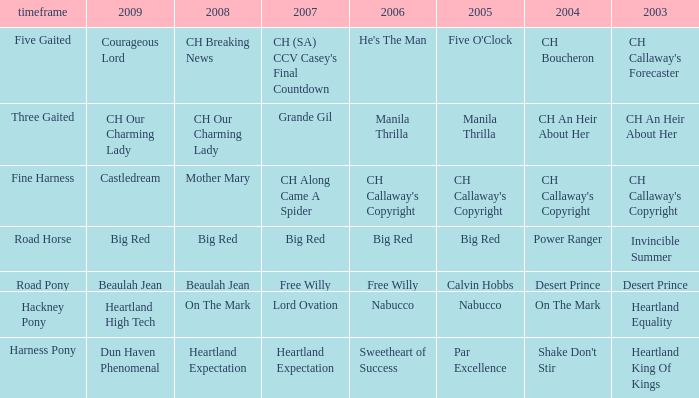What year is the 2004 shake don't stir? Harness Pony. 